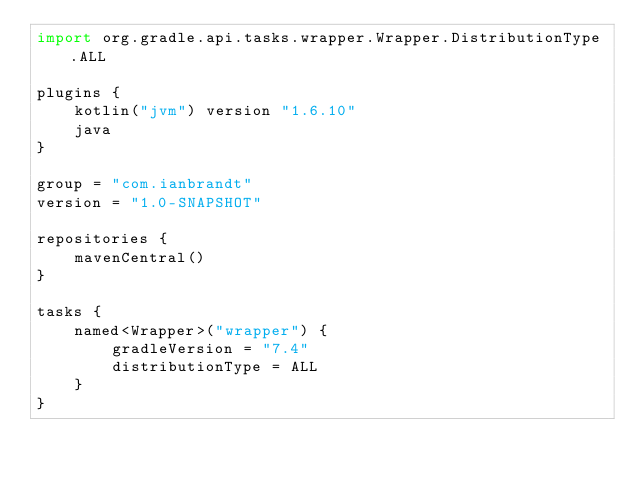Convert code to text. <code><loc_0><loc_0><loc_500><loc_500><_Kotlin_>import org.gradle.api.tasks.wrapper.Wrapper.DistributionType.ALL

plugins {
    kotlin("jvm") version "1.6.10"
    java
}

group = "com.ianbrandt"
version = "1.0-SNAPSHOT"

repositories {
    mavenCentral()
}

tasks {
    named<Wrapper>("wrapper") {
        gradleVersion = "7.4"
        distributionType = ALL
    }
}
</code> 